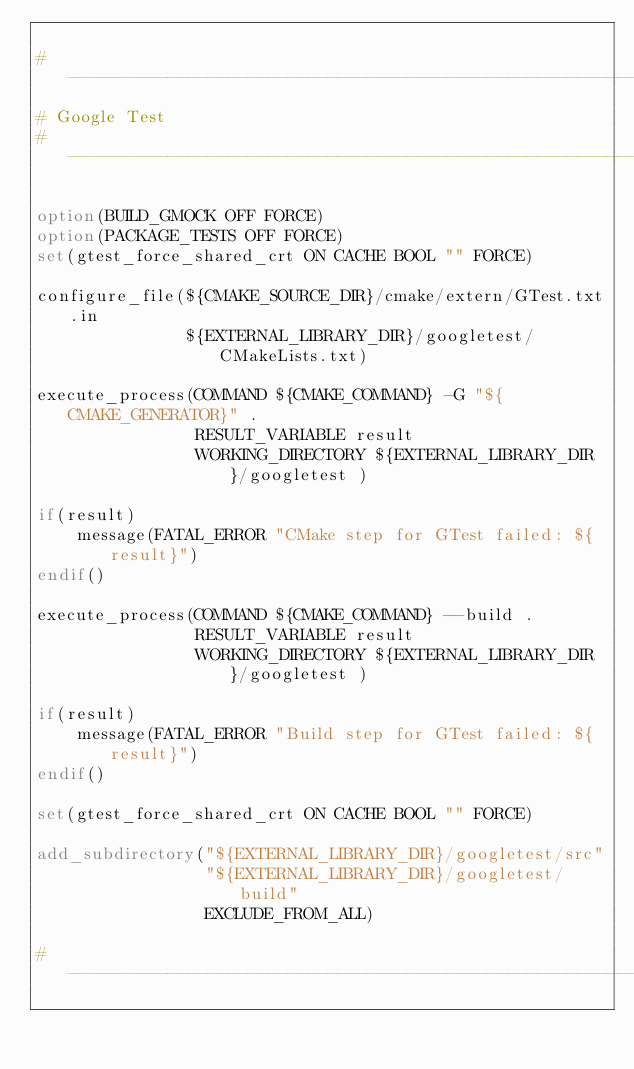Convert code to text. <code><loc_0><loc_0><loc_500><loc_500><_CMake_>
# ------------------------------------------------------------------------------
# Google Test
# ------------------------------------------------------------------------------

option(BUILD_GMOCK OFF FORCE)
option(PACKAGE_TESTS OFF FORCE)
set(gtest_force_shared_crt ON CACHE BOOL "" FORCE)

configure_file(${CMAKE_SOURCE_DIR}/cmake/extern/GTest.txt.in
               ${EXTERNAL_LIBRARY_DIR}/googletest/CMakeLists.txt)

execute_process(COMMAND ${CMAKE_COMMAND} -G "${CMAKE_GENERATOR}" .
                RESULT_VARIABLE result
                WORKING_DIRECTORY ${EXTERNAL_LIBRARY_DIR}/googletest )

if(result)
    message(FATAL_ERROR "CMake step for GTest failed: ${result}")
endif()

execute_process(COMMAND ${CMAKE_COMMAND} --build .
                RESULT_VARIABLE result
                WORKING_DIRECTORY ${EXTERNAL_LIBRARY_DIR}/googletest )

if(result)
    message(FATAL_ERROR "Build step for GTest failed: ${result}")
endif()

set(gtest_force_shared_crt ON CACHE BOOL "" FORCE)

add_subdirectory("${EXTERNAL_LIBRARY_DIR}/googletest/src"
                 "${EXTERNAL_LIBRARY_DIR}/googletest/build"
                 EXCLUDE_FROM_ALL)

# ------------------------------------------------------------------------------
</code> 